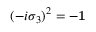Convert formula to latex. <formula><loc_0><loc_0><loc_500><loc_500>( - i \sigma _ { 3 } ) ^ { 2 } = - { 1 }</formula> 